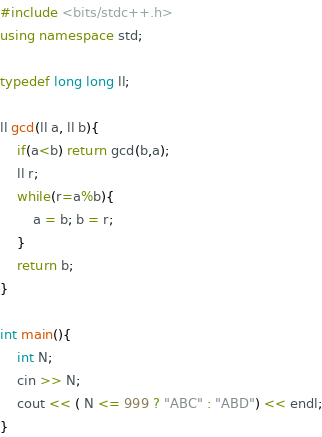Convert code to text. <code><loc_0><loc_0><loc_500><loc_500><_C++_>#include <bits/stdc++.h>
using namespace std;

typedef long long ll;

ll gcd(ll a, ll b){
    if(a<b) return gcd(b,a);
    ll r;
    while(r=a%b){
        a = b; b = r;
    }
    return b;
}

int main(){
    int N;
    cin >> N;
    cout << ( N <= 999 ? "ABC" : "ABD") << endl;
}
</code> 